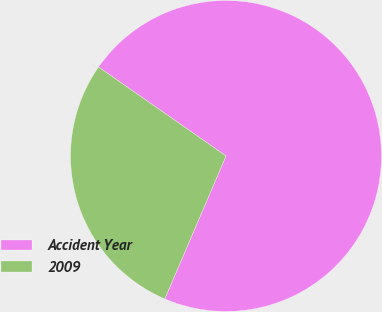Convert chart. <chart><loc_0><loc_0><loc_500><loc_500><pie_chart><fcel>Accident Year<fcel>2009<nl><fcel>71.74%<fcel>28.26%<nl></chart> 